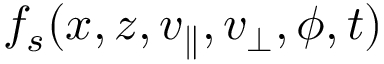Convert formula to latex. <formula><loc_0><loc_0><loc_500><loc_500>f _ { s } ( x , z , v _ { \| } , v _ { \perp } , \phi , t )</formula> 